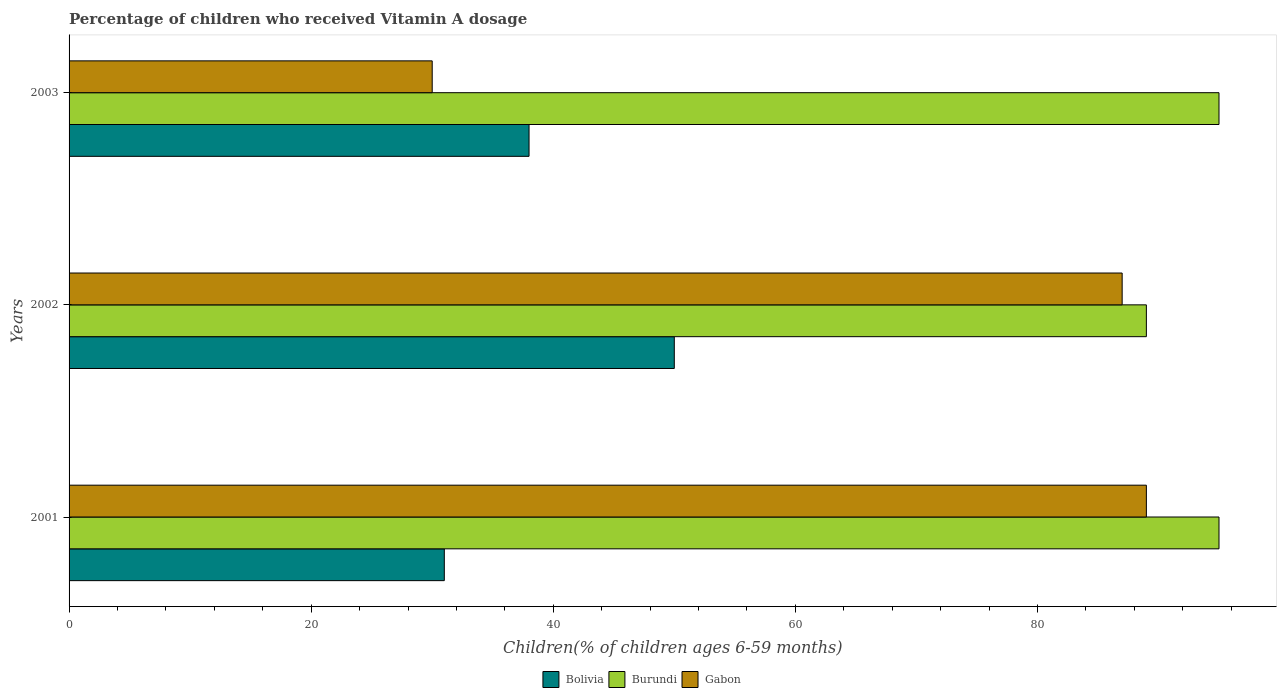How many different coloured bars are there?
Ensure brevity in your answer.  3. How many groups of bars are there?
Ensure brevity in your answer.  3. Are the number of bars on each tick of the Y-axis equal?
Offer a terse response. Yes. How many bars are there on the 1st tick from the bottom?
Your answer should be compact. 3. What is the percentage of children who received Vitamin A dosage in Bolivia in 2001?
Keep it short and to the point. 31. Across all years, what is the maximum percentage of children who received Vitamin A dosage in Bolivia?
Ensure brevity in your answer.  50. In which year was the percentage of children who received Vitamin A dosage in Burundi minimum?
Provide a short and direct response. 2002. What is the total percentage of children who received Vitamin A dosage in Burundi in the graph?
Your answer should be very brief. 279. What is the difference between the percentage of children who received Vitamin A dosage in Bolivia in 2001 and the percentage of children who received Vitamin A dosage in Gabon in 2002?
Provide a succinct answer. -56. What is the average percentage of children who received Vitamin A dosage in Gabon per year?
Your answer should be very brief. 68.67. What is the ratio of the percentage of children who received Vitamin A dosage in Gabon in 2001 to that in 2002?
Your response must be concise. 1.02. What is the difference between the highest and the lowest percentage of children who received Vitamin A dosage in Bolivia?
Make the answer very short. 19. Is the sum of the percentage of children who received Vitamin A dosage in Burundi in 2001 and 2003 greater than the maximum percentage of children who received Vitamin A dosage in Bolivia across all years?
Provide a succinct answer. Yes. What does the 2nd bar from the top in 2002 represents?
Provide a succinct answer. Burundi. What does the 1st bar from the bottom in 2001 represents?
Ensure brevity in your answer.  Bolivia. Are all the bars in the graph horizontal?
Ensure brevity in your answer.  Yes. Does the graph contain any zero values?
Make the answer very short. No. How many legend labels are there?
Offer a very short reply. 3. What is the title of the graph?
Ensure brevity in your answer.  Percentage of children who received Vitamin A dosage. Does "Vietnam" appear as one of the legend labels in the graph?
Your answer should be very brief. No. What is the label or title of the X-axis?
Give a very brief answer. Children(% of children ages 6-59 months). What is the label or title of the Y-axis?
Your answer should be very brief. Years. What is the Children(% of children ages 6-59 months) in Bolivia in 2001?
Offer a very short reply. 31. What is the Children(% of children ages 6-59 months) of Gabon in 2001?
Ensure brevity in your answer.  89. What is the Children(% of children ages 6-59 months) of Burundi in 2002?
Give a very brief answer. 89. What is the Children(% of children ages 6-59 months) in Gabon in 2002?
Offer a terse response. 87. Across all years, what is the maximum Children(% of children ages 6-59 months) in Gabon?
Make the answer very short. 89. Across all years, what is the minimum Children(% of children ages 6-59 months) in Burundi?
Keep it short and to the point. 89. What is the total Children(% of children ages 6-59 months) of Bolivia in the graph?
Offer a terse response. 119. What is the total Children(% of children ages 6-59 months) of Burundi in the graph?
Your response must be concise. 279. What is the total Children(% of children ages 6-59 months) of Gabon in the graph?
Provide a succinct answer. 206. What is the difference between the Children(% of children ages 6-59 months) in Gabon in 2001 and that in 2002?
Offer a very short reply. 2. What is the difference between the Children(% of children ages 6-59 months) of Burundi in 2001 and that in 2003?
Keep it short and to the point. 0. What is the difference between the Children(% of children ages 6-59 months) in Gabon in 2001 and that in 2003?
Ensure brevity in your answer.  59. What is the difference between the Children(% of children ages 6-59 months) of Burundi in 2002 and that in 2003?
Offer a very short reply. -6. What is the difference between the Children(% of children ages 6-59 months) in Gabon in 2002 and that in 2003?
Ensure brevity in your answer.  57. What is the difference between the Children(% of children ages 6-59 months) in Bolivia in 2001 and the Children(% of children ages 6-59 months) in Burundi in 2002?
Your response must be concise. -58. What is the difference between the Children(% of children ages 6-59 months) of Bolivia in 2001 and the Children(% of children ages 6-59 months) of Gabon in 2002?
Offer a terse response. -56. What is the difference between the Children(% of children ages 6-59 months) of Bolivia in 2001 and the Children(% of children ages 6-59 months) of Burundi in 2003?
Offer a very short reply. -64. What is the difference between the Children(% of children ages 6-59 months) in Bolivia in 2001 and the Children(% of children ages 6-59 months) in Gabon in 2003?
Keep it short and to the point. 1. What is the difference between the Children(% of children ages 6-59 months) in Bolivia in 2002 and the Children(% of children ages 6-59 months) in Burundi in 2003?
Offer a very short reply. -45. What is the average Children(% of children ages 6-59 months) in Bolivia per year?
Your answer should be compact. 39.67. What is the average Children(% of children ages 6-59 months) of Burundi per year?
Provide a succinct answer. 93. What is the average Children(% of children ages 6-59 months) of Gabon per year?
Provide a succinct answer. 68.67. In the year 2001, what is the difference between the Children(% of children ages 6-59 months) in Bolivia and Children(% of children ages 6-59 months) in Burundi?
Offer a terse response. -64. In the year 2001, what is the difference between the Children(% of children ages 6-59 months) in Bolivia and Children(% of children ages 6-59 months) in Gabon?
Provide a short and direct response. -58. In the year 2002, what is the difference between the Children(% of children ages 6-59 months) of Bolivia and Children(% of children ages 6-59 months) of Burundi?
Your answer should be compact. -39. In the year 2002, what is the difference between the Children(% of children ages 6-59 months) of Bolivia and Children(% of children ages 6-59 months) of Gabon?
Your answer should be very brief. -37. In the year 2003, what is the difference between the Children(% of children ages 6-59 months) of Bolivia and Children(% of children ages 6-59 months) of Burundi?
Provide a succinct answer. -57. In the year 2003, what is the difference between the Children(% of children ages 6-59 months) in Burundi and Children(% of children ages 6-59 months) in Gabon?
Your answer should be very brief. 65. What is the ratio of the Children(% of children ages 6-59 months) of Bolivia in 2001 to that in 2002?
Your answer should be very brief. 0.62. What is the ratio of the Children(% of children ages 6-59 months) in Burundi in 2001 to that in 2002?
Provide a short and direct response. 1.07. What is the ratio of the Children(% of children ages 6-59 months) in Bolivia in 2001 to that in 2003?
Offer a very short reply. 0.82. What is the ratio of the Children(% of children ages 6-59 months) of Gabon in 2001 to that in 2003?
Keep it short and to the point. 2.97. What is the ratio of the Children(% of children ages 6-59 months) of Bolivia in 2002 to that in 2003?
Keep it short and to the point. 1.32. What is the ratio of the Children(% of children ages 6-59 months) in Burundi in 2002 to that in 2003?
Provide a succinct answer. 0.94. What is the ratio of the Children(% of children ages 6-59 months) in Gabon in 2002 to that in 2003?
Your answer should be very brief. 2.9. What is the difference between the highest and the second highest Children(% of children ages 6-59 months) in Bolivia?
Make the answer very short. 12. What is the difference between the highest and the second highest Children(% of children ages 6-59 months) in Burundi?
Provide a short and direct response. 0. 